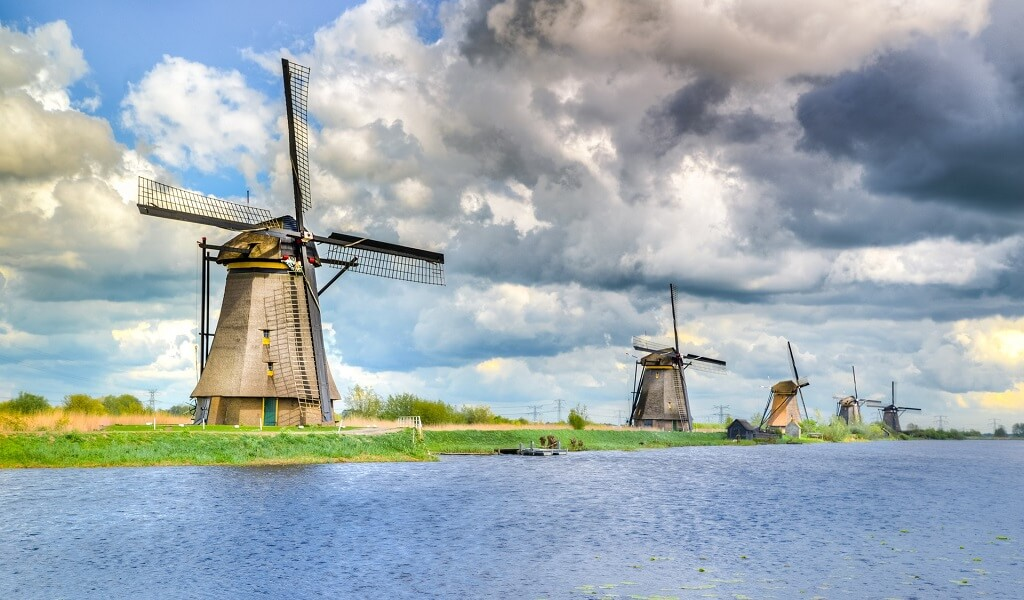What time of day do you think it is in this picture? Judging by the lighting and the position of shadows cast by the windmills, it appears to be in the late afternoon, possibly heading towards early evening. The golden hues in the sky and the lengthening shadows suggest that the sun is beginning to descend, casting a serene and warm glow over the landscape. Could you explain why these windmills were built and their historical significance? The Kinderdijk Windmills were constructed in the 18th century with a vital purpose: water management. The Netherlands is a country with considerable portions of land below sea level, making effective water control crucial. These windmills were designed to pump water from the low-lying areas into the higher river beds, preventing flooding and reclaiming land for agriculture and settlement. Over time, they became symbols of Dutch ingenuity and resilience, showcasing a brilliant fusion of functional engineering and environmental harmony. Today, the Kinderdijk Windmills are not only a UNESCO World Heritage Site but also icons of Dutch cultural heritage and technology, attracting visitors from all over the globe. 